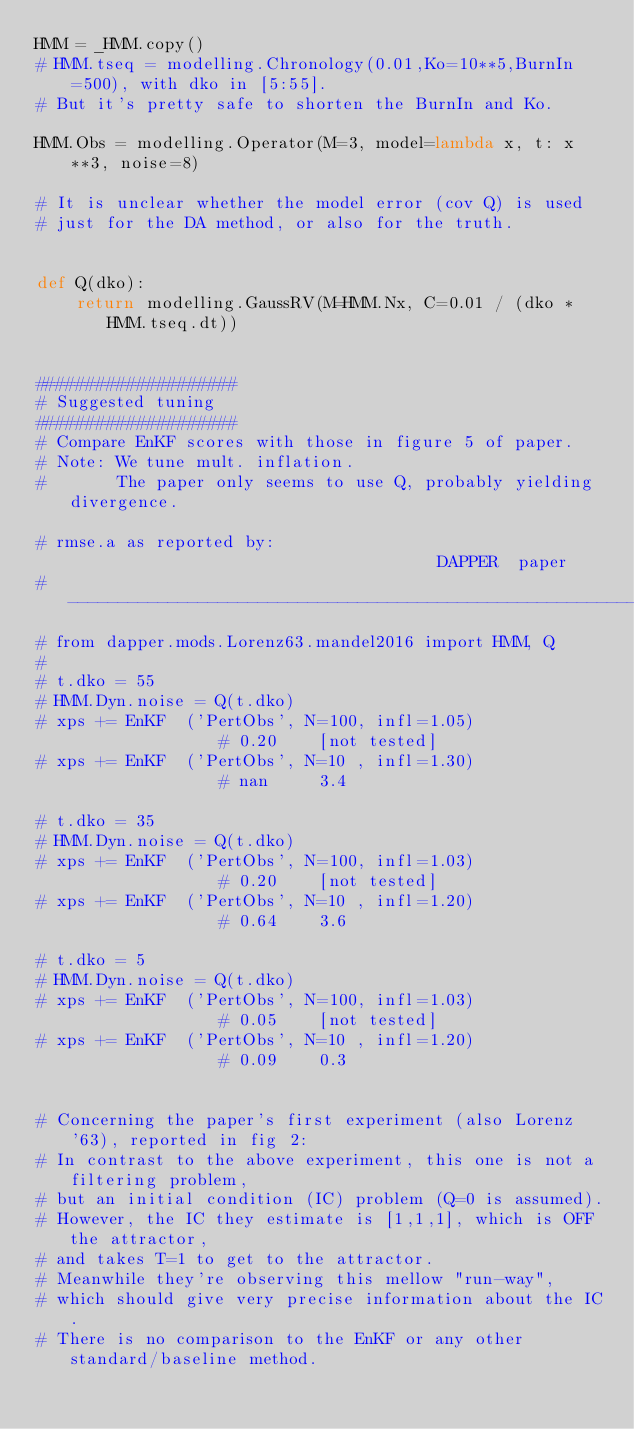<code> <loc_0><loc_0><loc_500><loc_500><_Python_>HMM = _HMM.copy()
# HMM.tseq = modelling.Chronology(0.01,Ko=10**5,BurnIn=500), with dko in [5:55].
# But it's pretty safe to shorten the BurnIn and Ko.

HMM.Obs = modelling.Operator(M=3, model=lambda x, t: x**3, noise=8)

# It is unclear whether the model error (cov Q) is used
# just for the DA method, or also for the truth.


def Q(dko):
    return modelling.GaussRV(M=HMM.Nx, C=0.01 / (dko * HMM.tseq.dt))


####################
# Suggested tuning
####################
# Compare EnKF scores with those in figure 5 of paper.
# Note: We tune mult. inflation.
#       The paper only seems to use Q, probably yielding divergence.

# rmse.a as reported by:                                      DAPPER  paper
# --------------------------------------------------------------------------
# from dapper.mods.Lorenz63.mandel2016 import HMM, Q
#
# t.dko = 55
# HMM.Dyn.noise = Q(t.dko)
# xps += EnKF  ('PertObs', N=100, infl=1.05)                # 0.20    [not tested]
# xps += EnKF  ('PertObs', N=10 , infl=1.30)                # nan     3.4

# t.dko = 35
# HMM.Dyn.noise = Q(t.dko)
# xps += EnKF  ('PertObs', N=100, infl=1.03)                # 0.20    [not tested]
# xps += EnKF  ('PertObs', N=10 , infl=1.20)                # 0.64    3.6

# t.dko = 5
# HMM.Dyn.noise = Q(t.dko)
# xps += EnKF  ('PertObs', N=100, infl=1.03)                # 0.05    [not tested]
# xps += EnKF  ('PertObs', N=10 , infl=1.20)                # 0.09    0.3


# Concerning the paper's first experiment (also Lorenz'63), reported in fig 2:
# In contrast to the above experiment, this one is not a filtering problem,
# but an initial condition (IC) problem (Q=0 is assumed).
# However, the IC they estimate is [1,1,1], which is OFF the attractor,
# and takes T=1 to get to the attractor.
# Meanwhile they're observing this mellow "run-way",
# which should give very precise information about the IC.
# There is no comparison to the EnKF or any other standard/baseline method.
</code> 